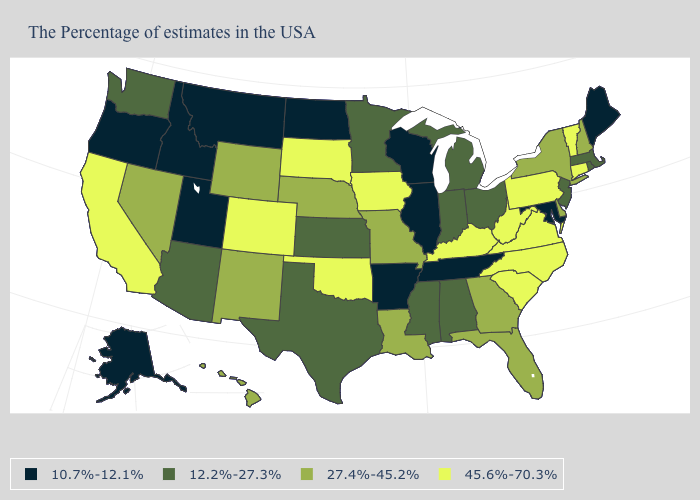What is the value of Connecticut?
Concise answer only. 45.6%-70.3%. What is the highest value in the West ?
Quick response, please. 45.6%-70.3%. Does the first symbol in the legend represent the smallest category?
Short answer required. Yes. What is the value of Maryland?
Answer briefly. 10.7%-12.1%. Does Iowa have a lower value than Louisiana?
Be succinct. No. What is the value of Wyoming?
Answer briefly. 27.4%-45.2%. Does the first symbol in the legend represent the smallest category?
Write a very short answer. Yes. Among the states that border Missouri , which have the highest value?
Concise answer only. Kentucky, Iowa, Oklahoma. How many symbols are there in the legend?
Be succinct. 4. Is the legend a continuous bar?
Answer briefly. No. What is the value of Tennessee?
Be succinct. 10.7%-12.1%. Which states hav the highest value in the West?
Concise answer only. Colorado, California. Is the legend a continuous bar?
Short answer required. No. Name the states that have a value in the range 12.2%-27.3%?
Quick response, please. Massachusetts, Rhode Island, New Jersey, Ohio, Michigan, Indiana, Alabama, Mississippi, Minnesota, Kansas, Texas, Arizona, Washington. Does Iowa have the highest value in the MidWest?
Give a very brief answer. Yes. 